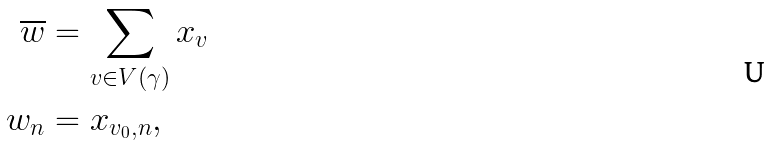Convert formula to latex. <formula><loc_0><loc_0><loc_500><loc_500>\overline { w } & = \sum _ { v \in V ( \gamma ) } x _ { v } \\ w _ { n } & = x _ { v _ { 0 } , n } ,</formula> 